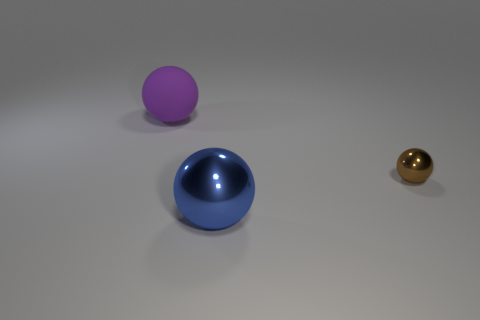What is the relative size of the objects to each other? The blue ball in the foreground is the largest, while the purple ball appears slightly smaller and is positioned further back. The brown ball is the smallest and is also the furthest away from the viewpoint. 